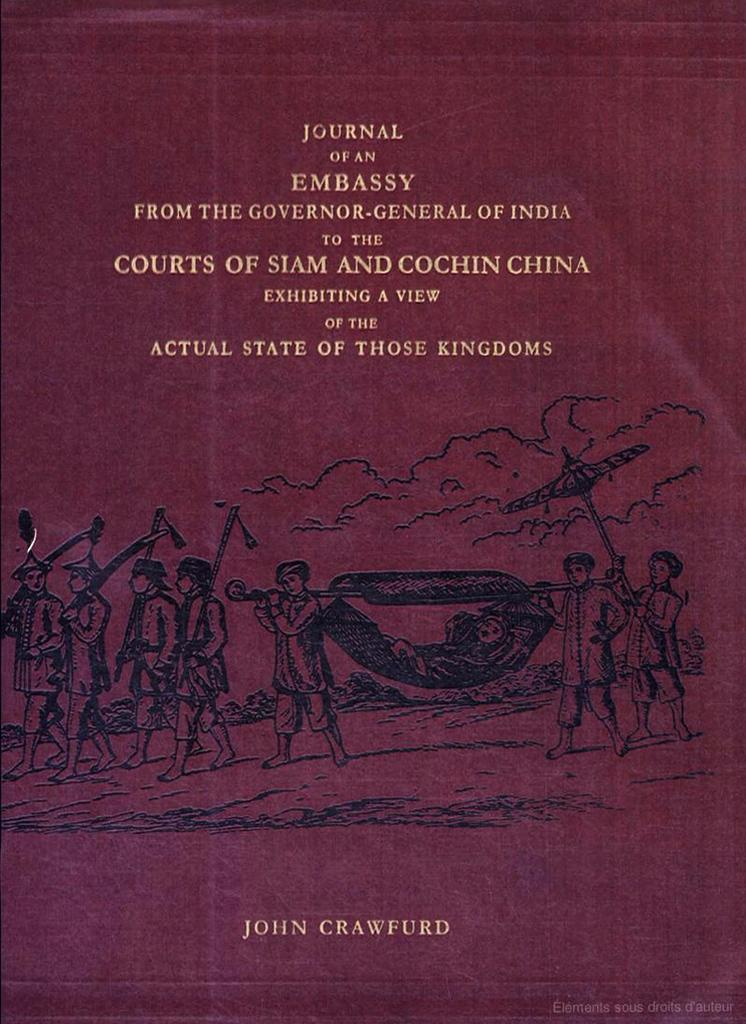<image>
Offer a succinct explanation of the picture presented. The cover of a book titled Journal of an Embassy. 